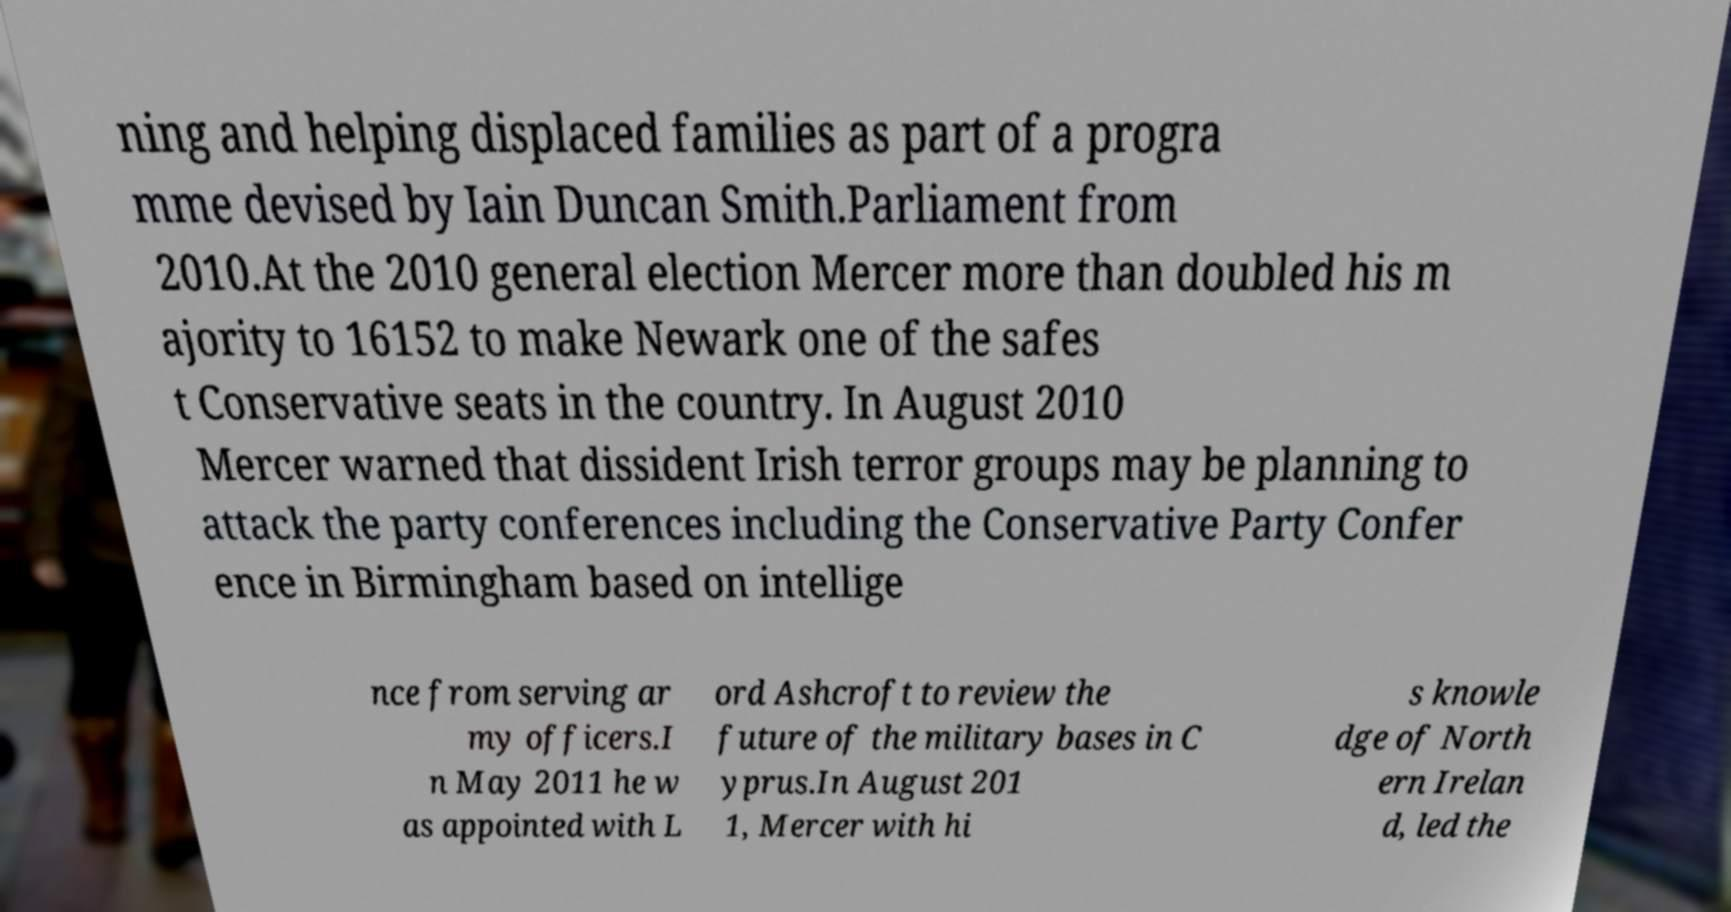What messages or text are displayed in this image? I need them in a readable, typed format. ning and helping displaced families as part of a progra mme devised by Iain Duncan Smith.Parliament from 2010.At the 2010 general election Mercer more than doubled his m ajority to 16152 to make Newark one of the safes t Conservative seats in the country. In August 2010 Mercer warned that dissident Irish terror groups may be planning to attack the party conferences including the Conservative Party Confer ence in Birmingham based on intellige nce from serving ar my officers.I n May 2011 he w as appointed with L ord Ashcroft to review the future of the military bases in C yprus.In August 201 1, Mercer with hi s knowle dge of North ern Irelan d, led the 